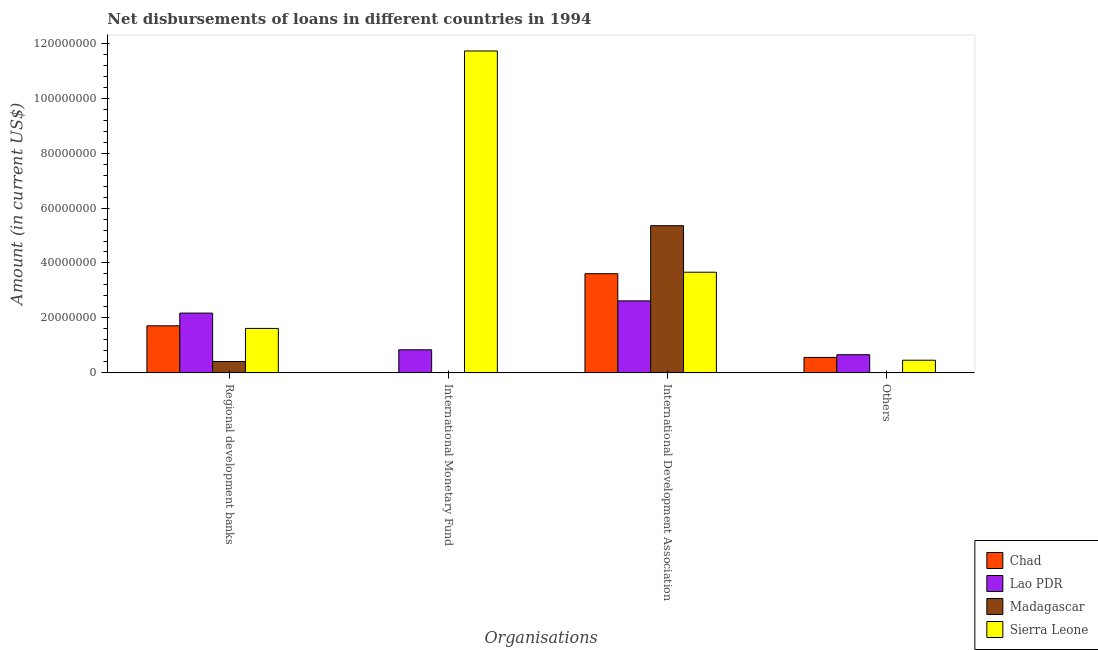How many different coloured bars are there?
Provide a succinct answer. 4. How many groups of bars are there?
Ensure brevity in your answer.  4. Are the number of bars per tick equal to the number of legend labels?
Offer a very short reply. No. What is the label of the 1st group of bars from the left?
Provide a succinct answer. Regional development banks. What is the amount of loan disimbursed by regional development banks in Madagascar?
Make the answer very short. 4.14e+06. Across all countries, what is the maximum amount of loan disimbursed by regional development banks?
Keep it short and to the point. 2.18e+07. Across all countries, what is the minimum amount of loan disimbursed by other organisations?
Your response must be concise. 0. In which country was the amount of loan disimbursed by international monetary fund maximum?
Provide a succinct answer. Sierra Leone. What is the total amount of loan disimbursed by international development association in the graph?
Make the answer very short. 1.53e+08. What is the difference between the amount of loan disimbursed by regional development banks in Madagascar and that in Chad?
Offer a very short reply. -1.30e+07. What is the difference between the amount of loan disimbursed by international monetary fund in Sierra Leone and the amount of loan disimbursed by other organisations in Lao PDR?
Your answer should be compact. 1.11e+08. What is the average amount of loan disimbursed by other organisations per country?
Make the answer very short. 4.21e+06. What is the difference between the amount of loan disimbursed by other organisations and amount of loan disimbursed by regional development banks in Lao PDR?
Provide a succinct answer. -1.52e+07. What is the ratio of the amount of loan disimbursed by international development association in Lao PDR to that in Chad?
Your answer should be very brief. 0.73. Is the amount of loan disimbursed by regional development banks in Chad less than that in Sierra Leone?
Ensure brevity in your answer.  No. Is the difference between the amount of loan disimbursed by international monetary fund in Sierra Leone and Lao PDR greater than the difference between the amount of loan disimbursed by international development association in Sierra Leone and Lao PDR?
Your answer should be compact. Yes. What is the difference between the highest and the second highest amount of loan disimbursed by other organisations?
Ensure brevity in your answer.  9.83e+05. What is the difference between the highest and the lowest amount of loan disimbursed by international monetary fund?
Offer a terse response. 1.17e+08. In how many countries, is the amount of loan disimbursed by international development association greater than the average amount of loan disimbursed by international development association taken over all countries?
Provide a short and direct response. 1. Is the sum of the amount of loan disimbursed by regional development banks in Chad and Lao PDR greater than the maximum amount of loan disimbursed by other organisations across all countries?
Your answer should be very brief. Yes. Are the values on the major ticks of Y-axis written in scientific E-notation?
Offer a very short reply. No. Where does the legend appear in the graph?
Your response must be concise. Bottom right. How many legend labels are there?
Offer a terse response. 4. How are the legend labels stacked?
Provide a short and direct response. Vertical. What is the title of the graph?
Provide a short and direct response. Net disbursements of loans in different countries in 1994. Does "West Bank and Gaza" appear as one of the legend labels in the graph?
Your answer should be very brief. No. What is the label or title of the X-axis?
Offer a very short reply. Organisations. What is the label or title of the Y-axis?
Ensure brevity in your answer.  Amount (in current US$). What is the Amount (in current US$) in Chad in Regional development banks?
Make the answer very short. 1.71e+07. What is the Amount (in current US$) of Lao PDR in Regional development banks?
Your answer should be compact. 2.18e+07. What is the Amount (in current US$) of Madagascar in Regional development banks?
Keep it short and to the point. 4.14e+06. What is the Amount (in current US$) in Sierra Leone in Regional development banks?
Give a very brief answer. 1.62e+07. What is the Amount (in current US$) in Chad in International Monetary Fund?
Keep it short and to the point. 0. What is the Amount (in current US$) of Lao PDR in International Monetary Fund?
Provide a short and direct response. 8.40e+06. What is the Amount (in current US$) of Madagascar in International Monetary Fund?
Your answer should be very brief. 0. What is the Amount (in current US$) in Sierra Leone in International Monetary Fund?
Offer a terse response. 1.17e+08. What is the Amount (in current US$) in Chad in International Development Association?
Your response must be concise. 3.61e+07. What is the Amount (in current US$) in Lao PDR in International Development Association?
Make the answer very short. 2.62e+07. What is the Amount (in current US$) of Madagascar in International Development Association?
Give a very brief answer. 5.36e+07. What is the Amount (in current US$) in Sierra Leone in International Development Association?
Give a very brief answer. 3.66e+07. What is the Amount (in current US$) in Chad in Others?
Keep it short and to the point. 5.62e+06. What is the Amount (in current US$) in Lao PDR in Others?
Keep it short and to the point. 6.60e+06. What is the Amount (in current US$) in Sierra Leone in Others?
Make the answer very short. 4.60e+06. Across all Organisations, what is the maximum Amount (in current US$) in Chad?
Make the answer very short. 3.61e+07. Across all Organisations, what is the maximum Amount (in current US$) of Lao PDR?
Offer a terse response. 2.62e+07. Across all Organisations, what is the maximum Amount (in current US$) in Madagascar?
Your answer should be very brief. 5.36e+07. Across all Organisations, what is the maximum Amount (in current US$) in Sierra Leone?
Make the answer very short. 1.17e+08. Across all Organisations, what is the minimum Amount (in current US$) of Lao PDR?
Offer a terse response. 6.60e+06. Across all Organisations, what is the minimum Amount (in current US$) of Sierra Leone?
Your answer should be compact. 4.60e+06. What is the total Amount (in current US$) of Chad in the graph?
Offer a very short reply. 5.89e+07. What is the total Amount (in current US$) in Lao PDR in the graph?
Offer a very short reply. 6.30e+07. What is the total Amount (in current US$) in Madagascar in the graph?
Provide a short and direct response. 5.77e+07. What is the total Amount (in current US$) in Sierra Leone in the graph?
Ensure brevity in your answer.  1.75e+08. What is the difference between the Amount (in current US$) of Lao PDR in Regional development banks and that in International Monetary Fund?
Give a very brief answer. 1.34e+07. What is the difference between the Amount (in current US$) of Sierra Leone in Regional development banks and that in International Monetary Fund?
Your answer should be compact. -1.01e+08. What is the difference between the Amount (in current US$) in Chad in Regional development banks and that in International Development Association?
Keep it short and to the point. -1.90e+07. What is the difference between the Amount (in current US$) of Lao PDR in Regional development banks and that in International Development Association?
Give a very brief answer. -4.45e+06. What is the difference between the Amount (in current US$) in Madagascar in Regional development banks and that in International Development Association?
Give a very brief answer. -4.94e+07. What is the difference between the Amount (in current US$) of Sierra Leone in Regional development banks and that in International Development Association?
Provide a short and direct response. -2.05e+07. What is the difference between the Amount (in current US$) of Chad in Regional development banks and that in Others?
Ensure brevity in your answer.  1.15e+07. What is the difference between the Amount (in current US$) in Lao PDR in Regional development banks and that in Others?
Provide a succinct answer. 1.52e+07. What is the difference between the Amount (in current US$) in Sierra Leone in Regional development banks and that in Others?
Your answer should be very brief. 1.16e+07. What is the difference between the Amount (in current US$) in Lao PDR in International Monetary Fund and that in International Development Association?
Provide a short and direct response. -1.78e+07. What is the difference between the Amount (in current US$) of Sierra Leone in International Monetary Fund and that in International Development Association?
Your response must be concise. 8.05e+07. What is the difference between the Amount (in current US$) of Lao PDR in International Monetary Fund and that in Others?
Offer a terse response. 1.80e+06. What is the difference between the Amount (in current US$) of Sierra Leone in International Monetary Fund and that in Others?
Keep it short and to the point. 1.13e+08. What is the difference between the Amount (in current US$) in Chad in International Development Association and that in Others?
Your answer should be very brief. 3.05e+07. What is the difference between the Amount (in current US$) of Lao PDR in International Development Association and that in Others?
Provide a succinct answer. 1.96e+07. What is the difference between the Amount (in current US$) in Sierra Leone in International Development Association and that in Others?
Your answer should be compact. 3.20e+07. What is the difference between the Amount (in current US$) in Chad in Regional development banks and the Amount (in current US$) in Lao PDR in International Monetary Fund?
Offer a terse response. 8.73e+06. What is the difference between the Amount (in current US$) in Chad in Regional development banks and the Amount (in current US$) in Sierra Leone in International Monetary Fund?
Ensure brevity in your answer.  -1.00e+08. What is the difference between the Amount (in current US$) of Lao PDR in Regional development banks and the Amount (in current US$) of Sierra Leone in International Monetary Fund?
Your answer should be compact. -9.54e+07. What is the difference between the Amount (in current US$) in Madagascar in Regional development banks and the Amount (in current US$) in Sierra Leone in International Monetary Fund?
Make the answer very short. -1.13e+08. What is the difference between the Amount (in current US$) of Chad in Regional development banks and the Amount (in current US$) of Lao PDR in International Development Association?
Provide a short and direct response. -9.08e+06. What is the difference between the Amount (in current US$) in Chad in Regional development banks and the Amount (in current US$) in Madagascar in International Development Association?
Offer a very short reply. -3.64e+07. What is the difference between the Amount (in current US$) of Chad in Regional development banks and the Amount (in current US$) of Sierra Leone in International Development Association?
Offer a terse response. -1.95e+07. What is the difference between the Amount (in current US$) of Lao PDR in Regional development banks and the Amount (in current US$) of Madagascar in International Development Association?
Provide a succinct answer. -3.18e+07. What is the difference between the Amount (in current US$) of Lao PDR in Regional development banks and the Amount (in current US$) of Sierra Leone in International Development Association?
Keep it short and to the point. -1.49e+07. What is the difference between the Amount (in current US$) of Madagascar in Regional development banks and the Amount (in current US$) of Sierra Leone in International Development Association?
Ensure brevity in your answer.  -3.25e+07. What is the difference between the Amount (in current US$) of Chad in Regional development banks and the Amount (in current US$) of Lao PDR in Others?
Give a very brief answer. 1.05e+07. What is the difference between the Amount (in current US$) in Chad in Regional development banks and the Amount (in current US$) in Sierra Leone in Others?
Provide a succinct answer. 1.25e+07. What is the difference between the Amount (in current US$) in Lao PDR in Regional development banks and the Amount (in current US$) in Sierra Leone in Others?
Keep it short and to the point. 1.72e+07. What is the difference between the Amount (in current US$) of Madagascar in Regional development banks and the Amount (in current US$) of Sierra Leone in Others?
Give a very brief answer. -4.64e+05. What is the difference between the Amount (in current US$) in Lao PDR in International Monetary Fund and the Amount (in current US$) in Madagascar in International Development Association?
Offer a terse response. -4.52e+07. What is the difference between the Amount (in current US$) of Lao PDR in International Monetary Fund and the Amount (in current US$) of Sierra Leone in International Development Association?
Offer a very short reply. -2.82e+07. What is the difference between the Amount (in current US$) in Lao PDR in International Monetary Fund and the Amount (in current US$) in Sierra Leone in Others?
Make the answer very short. 3.80e+06. What is the difference between the Amount (in current US$) in Chad in International Development Association and the Amount (in current US$) in Lao PDR in Others?
Your answer should be very brief. 2.95e+07. What is the difference between the Amount (in current US$) in Chad in International Development Association and the Amount (in current US$) in Sierra Leone in Others?
Your answer should be very brief. 3.15e+07. What is the difference between the Amount (in current US$) in Lao PDR in International Development Association and the Amount (in current US$) in Sierra Leone in Others?
Your response must be concise. 2.16e+07. What is the difference between the Amount (in current US$) in Madagascar in International Development Association and the Amount (in current US$) in Sierra Leone in Others?
Offer a very short reply. 4.90e+07. What is the average Amount (in current US$) of Chad per Organisations?
Your response must be concise. 1.47e+07. What is the average Amount (in current US$) of Lao PDR per Organisations?
Provide a succinct answer. 1.57e+07. What is the average Amount (in current US$) in Madagascar per Organisations?
Give a very brief answer. 1.44e+07. What is the average Amount (in current US$) of Sierra Leone per Organisations?
Your response must be concise. 4.36e+07. What is the difference between the Amount (in current US$) of Chad and Amount (in current US$) of Lao PDR in Regional development banks?
Your response must be concise. -4.63e+06. What is the difference between the Amount (in current US$) of Chad and Amount (in current US$) of Madagascar in Regional development banks?
Provide a short and direct response. 1.30e+07. What is the difference between the Amount (in current US$) in Chad and Amount (in current US$) in Sierra Leone in Regional development banks?
Give a very brief answer. 9.53e+05. What is the difference between the Amount (in current US$) of Lao PDR and Amount (in current US$) of Madagascar in Regional development banks?
Provide a succinct answer. 1.76e+07. What is the difference between the Amount (in current US$) of Lao PDR and Amount (in current US$) of Sierra Leone in Regional development banks?
Offer a very short reply. 5.58e+06. What is the difference between the Amount (in current US$) of Madagascar and Amount (in current US$) of Sierra Leone in Regional development banks?
Your response must be concise. -1.20e+07. What is the difference between the Amount (in current US$) in Lao PDR and Amount (in current US$) in Sierra Leone in International Monetary Fund?
Your answer should be very brief. -1.09e+08. What is the difference between the Amount (in current US$) of Chad and Amount (in current US$) of Lao PDR in International Development Association?
Your answer should be compact. 9.90e+06. What is the difference between the Amount (in current US$) in Chad and Amount (in current US$) in Madagascar in International Development Association?
Your answer should be very brief. -1.75e+07. What is the difference between the Amount (in current US$) of Chad and Amount (in current US$) of Sierra Leone in International Development Association?
Your response must be concise. -5.31e+05. What is the difference between the Amount (in current US$) of Lao PDR and Amount (in current US$) of Madagascar in International Development Association?
Your answer should be compact. -2.74e+07. What is the difference between the Amount (in current US$) in Lao PDR and Amount (in current US$) in Sierra Leone in International Development Association?
Offer a terse response. -1.04e+07. What is the difference between the Amount (in current US$) in Madagascar and Amount (in current US$) in Sierra Leone in International Development Association?
Ensure brevity in your answer.  1.69e+07. What is the difference between the Amount (in current US$) in Chad and Amount (in current US$) in Lao PDR in Others?
Give a very brief answer. -9.83e+05. What is the difference between the Amount (in current US$) of Chad and Amount (in current US$) of Sierra Leone in Others?
Provide a succinct answer. 1.02e+06. What is the difference between the Amount (in current US$) in Lao PDR and Amount (in current US$) in Sierra Leone in Others?
Provide a succinct answer. 2.00e+06. What is the ratio of the Amount (in current US$) of Lao PDR in Regional development banks to that in International Monetary Fund?
Ensure brevity in your answer.  2.59. What is the ratio of the Amount (in current US$) of Sierra Leone in Regional development banks to that in International Monetary Fund?
Provide a short and direct response. 0.14. What is the ratio of the Amount (in current US$) of Chad in Regional development banks to that in International Development Association?
Provide a succinct answer. 0.47. What is the ratio of the Amount (in current US$) of Lao PDR in Regional development banks to that in International Development Association?
Provide a succinct answer. 0.83. What is the ratio of the Amount (in current US$) of Madagascar in Regional development banks to that in International Development Association?
Keep it short and to the point. 0.08. What is the ratio of the Amount (in current US$) of Sierra Leone in Regional development banks to that in International Development Association?
Ensure brevity in your answer.  0.44. What is the ratio of the Amount (in current US$) in Chad in Regional development banks to that in Others?
Make the answer very short. 3.05. What is the ratio of the Amount (in current US$) in Lao PDR in Regional development banks to that in Others?
Your response must be concise. 3.29. What is the ratio of the Amount (in current US$) in Sierra Leone in Regional development banks to that in Others?
Your answer should be compact. 3.52. What is the ratio of the Amount (in current US$) of Lao PDR in International Monetary Fund to that in International Development Association?
Give a very brief answer. 0.32. What is the ratio of the Amount (in current US$) of Sierra Leone in International Monetary Fund to that in International Development Association?
Keep it short and to the point. 3.2. What is the ratio of the Amount (in current US$) of Lao PDR in International Monetary Fund to that in Others?
Keep it short and to the point. 1.27. What is the ratio of the Amount (in current US$) in Sierra Leone in International Monetary Fund to that in Others?
Ensure brevity in your answer.  25.47. What is the ratio of the Amount (in current US$) of Chad in International Development Association to that in Others?
Ensure brevity in your answer.  6.42. What is the ratio of the Amount (in current US$) in Lao PDR in International Development Association to that in Others?
Your answer should be very brief. 3.97. What is the ratio of the Amount (in current US$) in Sierra Leone in International Development Association to that in Others?
Give a very brief answer. 7.96. What is the difference between the highest and the second highest Amount (in current US$) in Chad?
Ensure brevity in your answer.  1.90e+07. What is the difference between the highest and the second highest Amount (in current US$) in Lao PDR?
Keep it short and to the point. 4.45e+06. What is the difference between the highest and the second highest Amount (in current US$) of Sierra Leone?
Provide a short and direct response. 8.05e+07. What is the difference between the highest and the lowest Amount (in current US$) of Chad?
Give a very brief answer. 3.61e+07. What is the difference between the highest and the lowest Amount (in current US$) of Lao PDR?
Offer a terse response. 1.96e+07. What is the difference between the highest and the lowest Amount (in current US$) of Madagascar?
Keep it short and to the point. 5.36e+07. What is the difference between the highest and the lowest Amount (in current US$) in Sierra Leone?
Provide a short and direct response. 1.13e+08. 